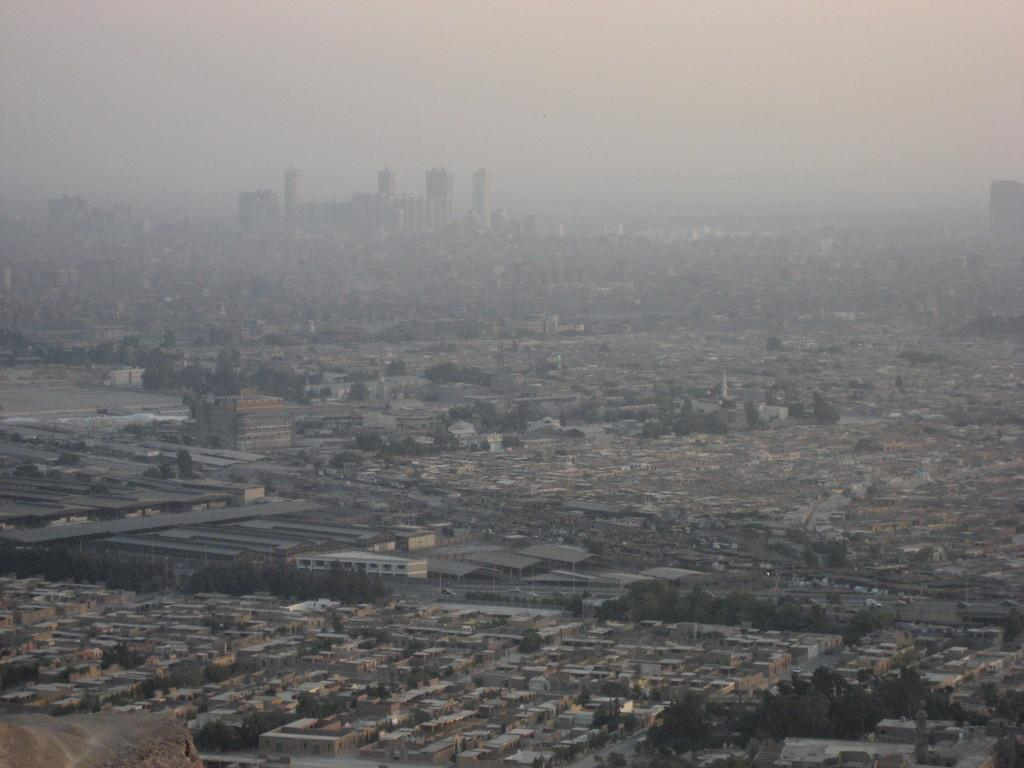What type of view is shown in the image? The image is an aerial view. What structures can be seen in the image? There are buildings in the image. What type of vegetation is present in the image? There are trees in the image. What is the background of the image? The sky is visible in the background of the image. What type of net is being used to catch the yam in the image? There is no net or yam present in the image. 